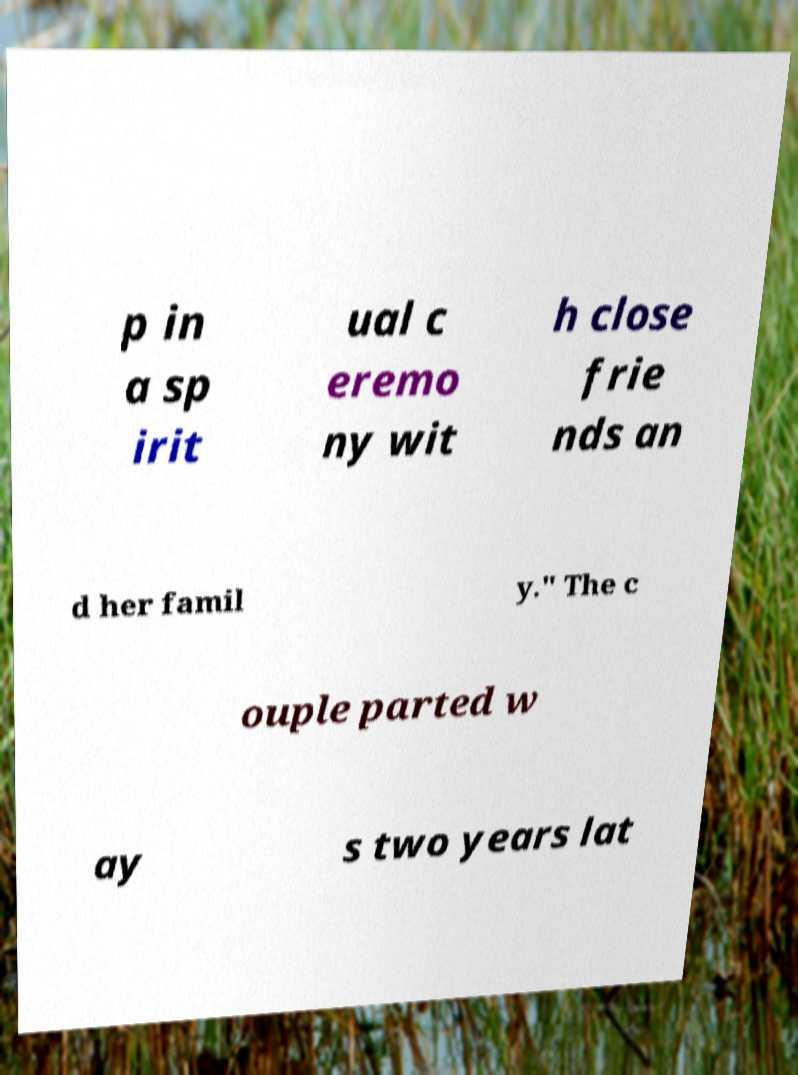Could you extract and type out the text from this image? p in a sp irit ual c eremo ny wit h close frie nds an d her famil y." The c ouple parted w ay s two years lat 